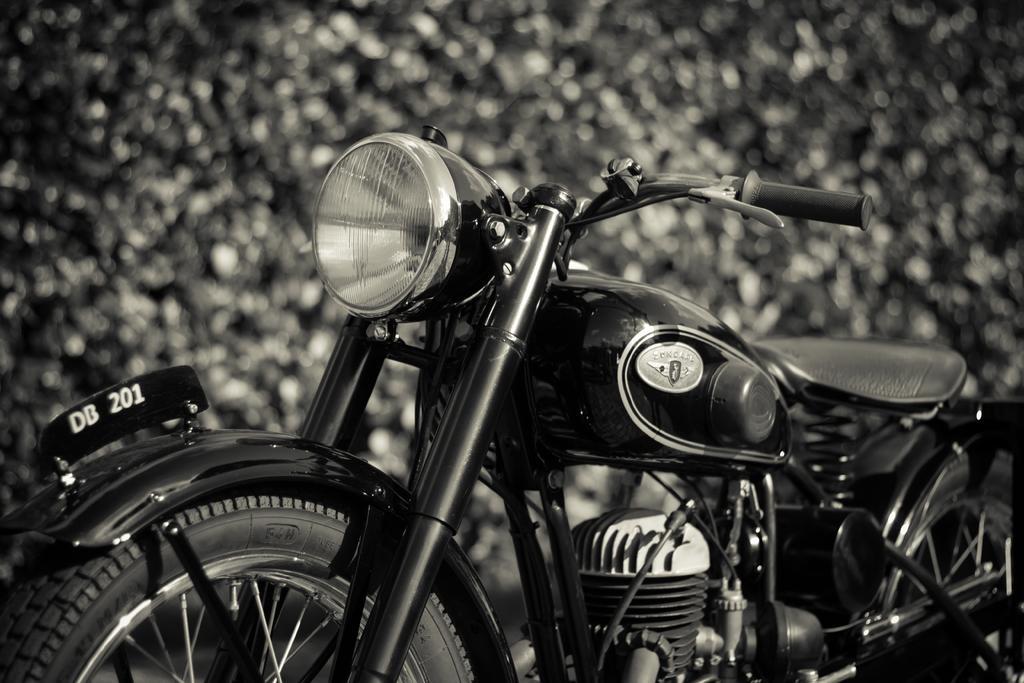Could you give a brief overview of what you see in this image? This is a black and white picture. In the foreground there is a motorbike. The background is blurred. 